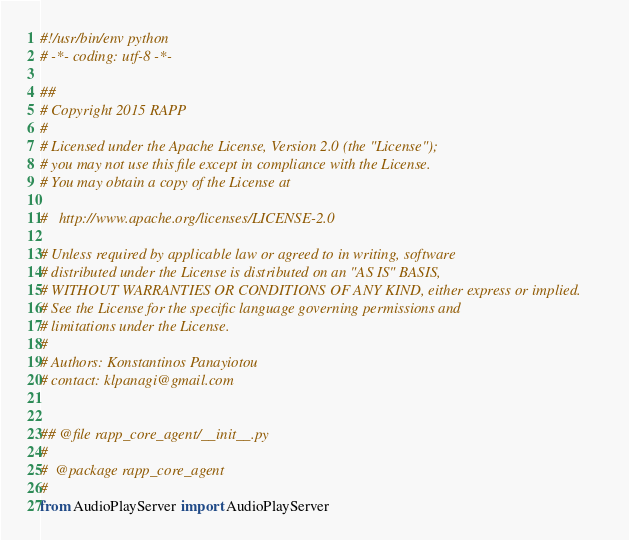<code> <loc_0><loc_0><loc_500><loc_500><_Python_>#!/usr/bin/env python
# -*- coding: utf-8 -*-

##
# Copyright 2015 RAPP
#
# Licensed under the Apache License, Version 2.0 (the "License");
# you may not use this file except in compliance with the License.
# You may obtain a copy of the License at

#   http://www.apache.org/licenses/LICENSE-2.0

# Unless required by applicable law or agreed to in writing, software
# distributed under the License is distributed on an "AS IS" BASIS,
# WITHOUT WARRANTIES OR CONDITIONS OF ANY KIND, either express or implied.
# See the License for the specific language governing permissions and
# limitations under the License.
#
# Authors: Konstantinos Panayiotou
# contact: klpanagi@gmail.com


## @file rapp_core_agent/__init__.py
#
#  @package rapp_core_agent
#
from AudioPlayServer import AudioPlayServer
</code> 